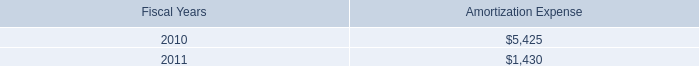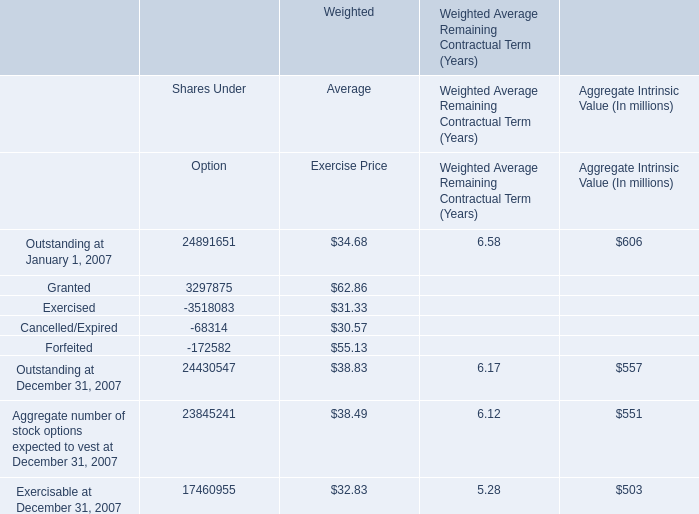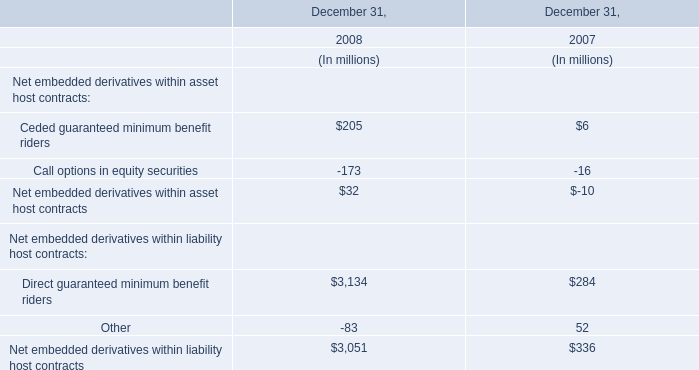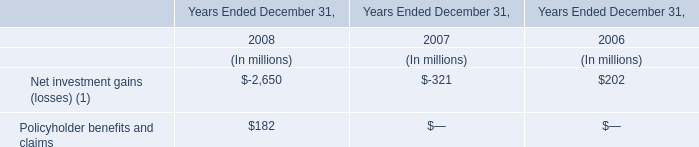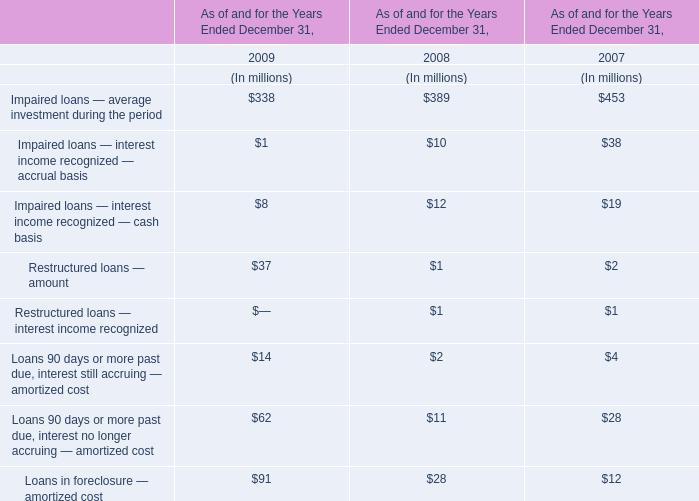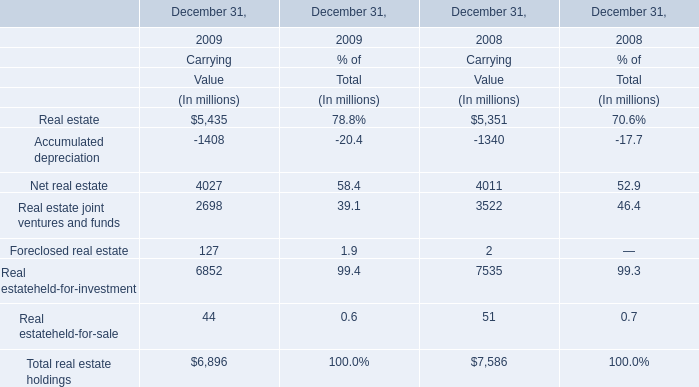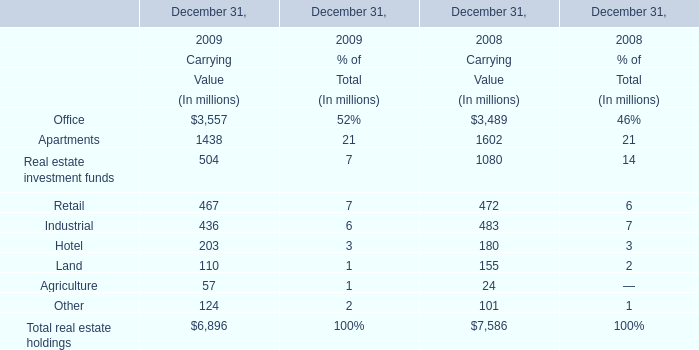What was the average of the Real estate in the years where Net real estate is positive for CarryingValue ? (in million) 
Computations: ((5435 + 5351) / 2)
Answer: 5393.0. 